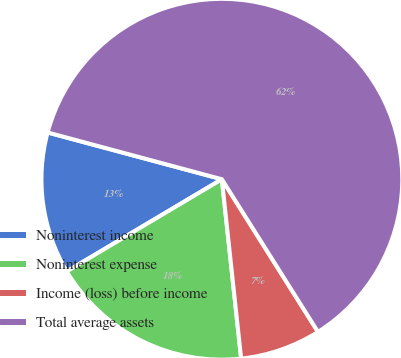Convert chart. <chart><loc_0><loc_0><loc_500><loc_500><pie_chart><fcel>Noninterest income<fcel>Noninterest expense<fcel>Income (loss) before income<fcel>Total average assets<nl><fcel>12.71%<fcel>18.17%<fcel>7.24%<fcel>61.88%<nl></chart> 